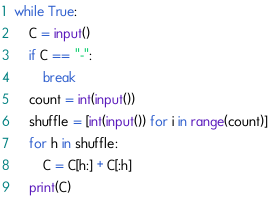Convert code to text. <code><loc_0><loc_0><loc_500><loc_500><_Python_>while True:
    C = input()
    if C == "-":
        break
    count = int(input())
    shuffle = [int(input()) for i in range(count)]
    for h in shuffle:
        C = C[h:] + C[:h]
    print(C)</code> 